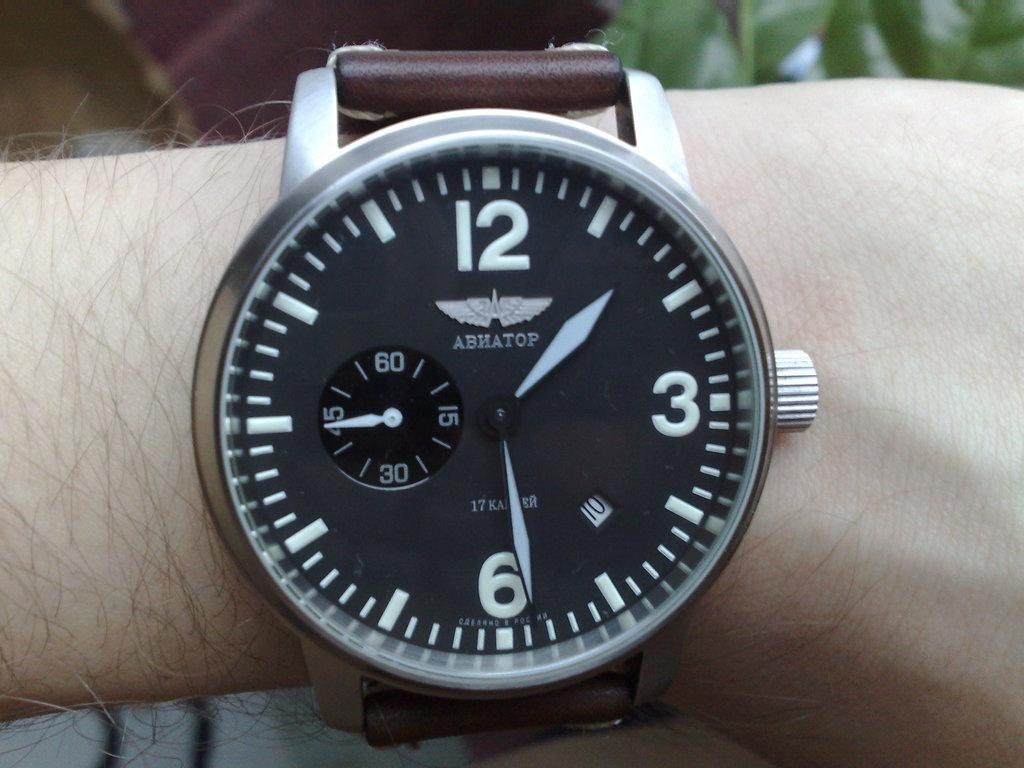<image>
Present a compact description of the photo's key features. An Abhatop wrist watch with a large face. 